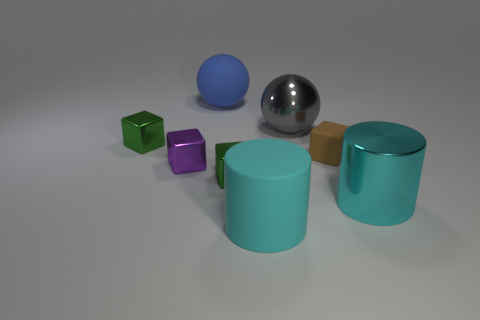Subtract all purple blocks. How many blocks are left? 3 Add 2 big cyan objects. How many objects exist? 10 Subtract all green blocks. How many blocks are left? 2 Subtract all cyan spheres. How many green blocks are left? 2 Add 7 cyan rubber objects. How many cyan rubber objects exist? 8 Subtract 0 red cubes. How many objects are left? 8 Subtract all spheres. How many objects are left? 6 Subtract 1 cylinders. How many cylinders are left? 1 Subtract all blue spheres. Subtract all green cylinders. How many spheres are left? 1 Subtract all tiny green objects. Subtract all tiny metallic things. How many objects are left? 3 